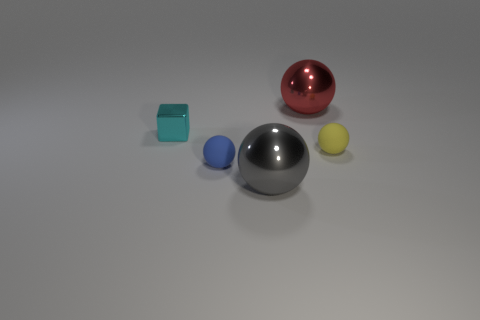What number of things are either shiny things that are in front of the metallic cube or large shiny objects in front of the small yellow object?
Your answer should be very brief. 1. How many other things are the same color as the shiny cube?
Your response must be concise. 0. Is the number of tiny yellow spheres to the left of the red sphere less than the number of large red metallic things behind the gray metallic object?
Your answer should be very brief. Yes. What number of small rubber balls are there?
Give a very brief answer. 2. Is there any other thing that has the same material as the red sphere?
Offer a terse response. Yes. There is a red object that is the same shape as the blue rubber thing; what is its material?
Offer a terse response. Metal. Is the number of red objects that are right of the small yellow ball less than the number of big blue objects?
Give a very brief answer. No. Is the shape of the metallic object that is in front of the small cyan metal cube the same as  the tiny yellow thing?
Offer a terse response. Yes. Are there any other things that are the same color as the tiny metal object?
Offer a very short reply. No. The red ball that is the same material as the big gray ball is what size?
Your answer should be very brief. Large. 